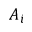<formula> <loc_0><loc_0><loc_500><loc_500>A _ { i }</formula> 